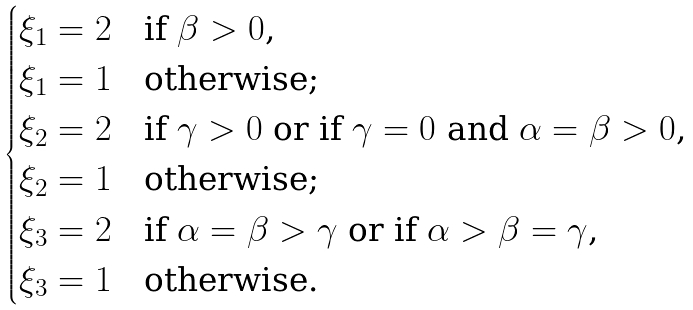<formula> <loc_0><loc_0><loc_500><loc_500>\begin{cases} \xi _ { 1 } = 2 & \text {if $\beta > 0$,} \\ \xi _ { 1 } = 1 & \text {otherwise;} \\ \xi _ { 2 } = 2 & \text {if $\gamma>0$ or if $\gamma = 0$ and $\alpha = \beta >0$,} \\ \xi _ { 2 } = 1 & \text {otherwise;} \\ \xi _ { 3 } = 2 & \text {if $\alpha = \beta > \gamma$ or if $\alpha > \beta = \gamma$,} \\ \xi _ { 3 } = 1 & \text {otherwise.} \end{cases}</formula> 